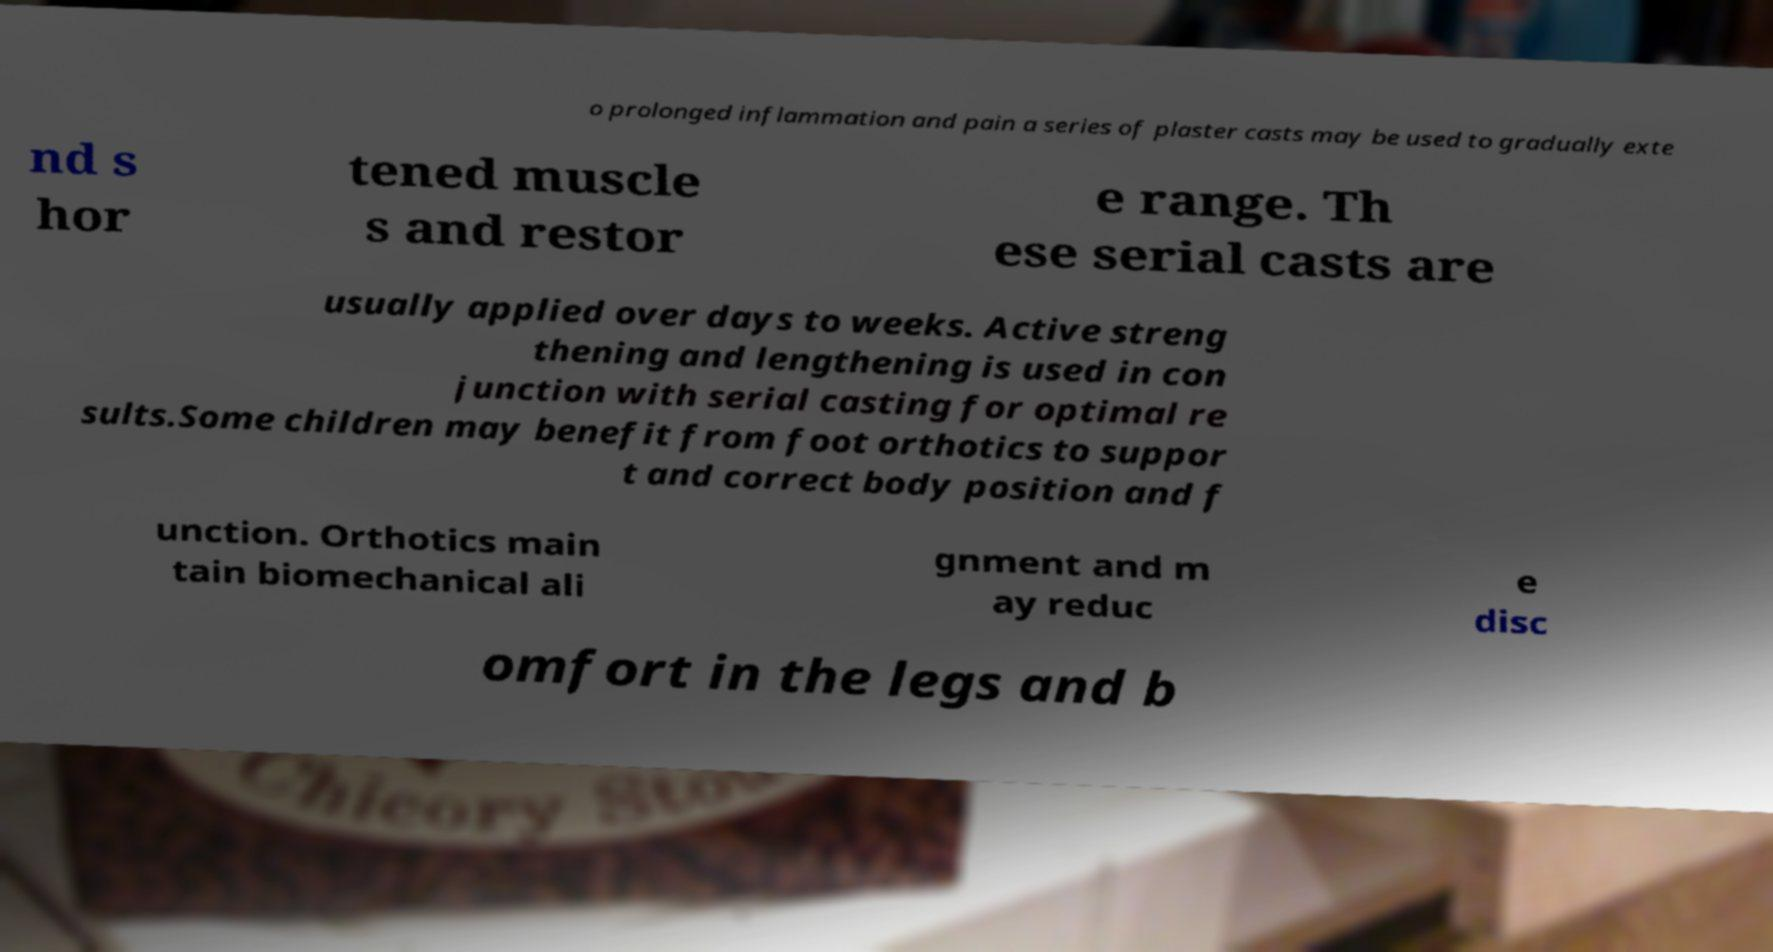There's text embedded in this image that I need extracted. Can you transcribe it verbatim? o prolonged inflammation and pain a series of plaster casts may be used to gradually exte nd s hor tened muscle s and restor e range. Th ese serial casts are usually applied over days to weeks. Active streng thening and lengthening is used in con junction with serial casting for optimal re sults.Some children may benefit from foot orthotics to suppor t and correct body position and f unction. Orthotics main tain biomechanical ali gnment and m ay reduc e disc omfort in the legs and b 